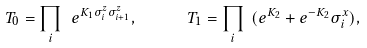<formula> <loc_0><loc_0><loc_500><loc_500>T _ { 0 } = \prod _ { i } \ e ^ { K _ { 1 } \sigma ^ { z } _ { i } \sigma ^ { z } _ { i + 1 } } , \quad \ \ T _ { 1 } = \prod _ { i } \ ( e ^ { K _ { 2 } } + e ^ { - K _ { 2 } } \sigma ^ { x } _ { i } ) ,</formula> 